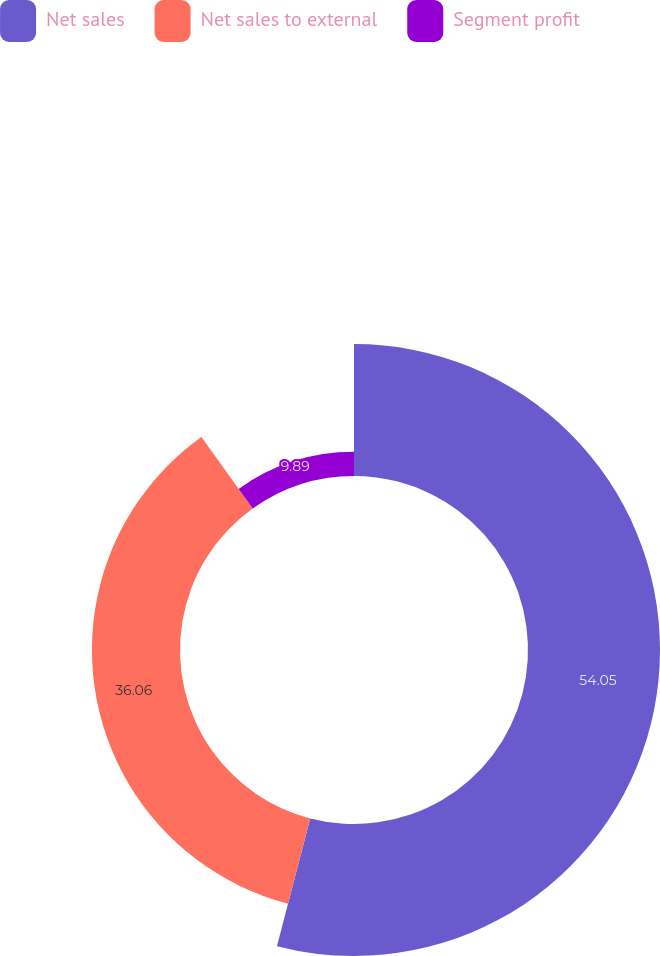Convert chart to OTSL. <chart><loc_0><loc_0><loc_500><loc_500><pie_chart><fcel>Net sales<fcel>Net sales to external<fcel>Segment profit<nl><fcel>54.05%<fcel>36.06%<fcel>9.89%<nl></chart> 